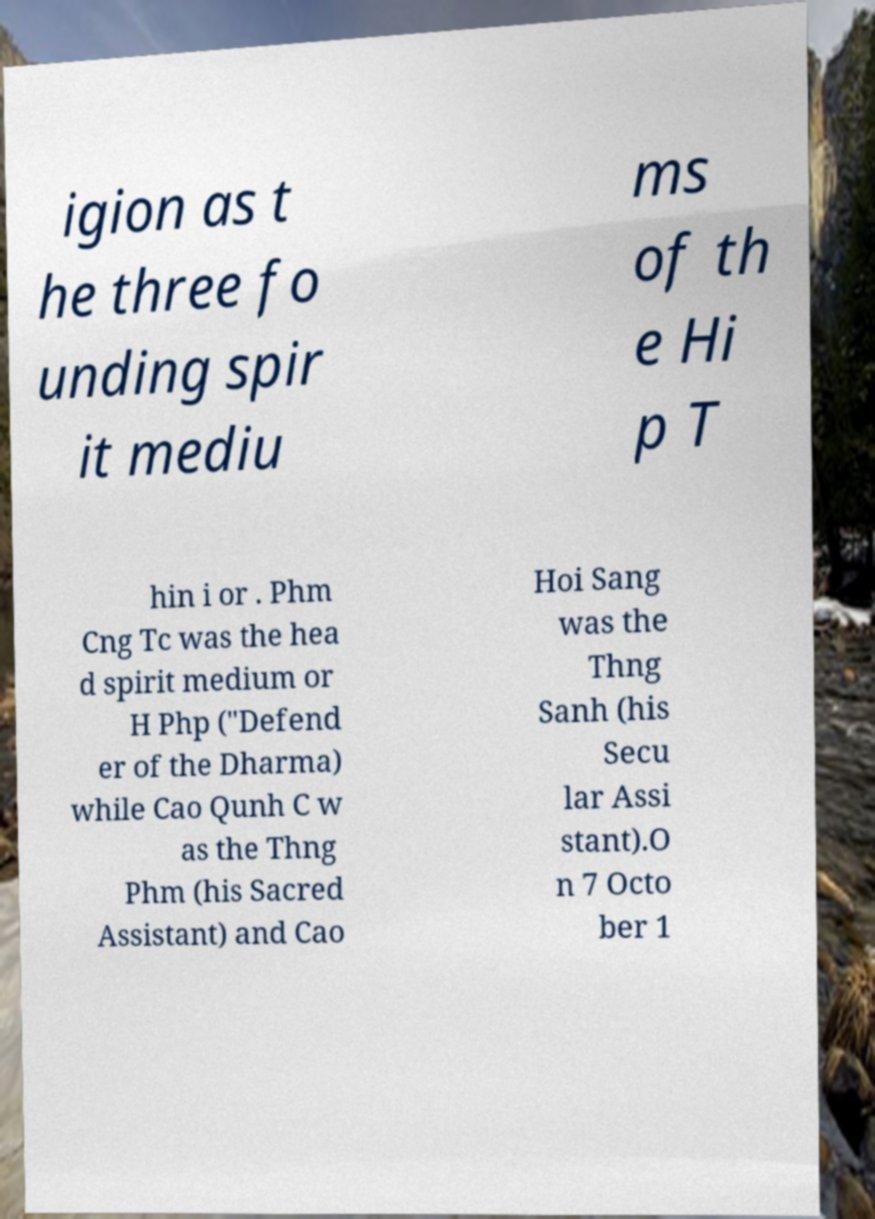Please identify and transcribe the text found in this image. igion as t he three fo unding spir it mediu ms of th e Hi p T hin i or . Phm Cng Tc was the hea d spirit medium or H Php ("Defend er of the Dharma) while Cao Qunh C w as the Thng Phm (his Sacred Assistant) and Cao Hoi Sang was the Thng Sanh (his Secu lar Assi stant).O n 7 Octo ber 1 